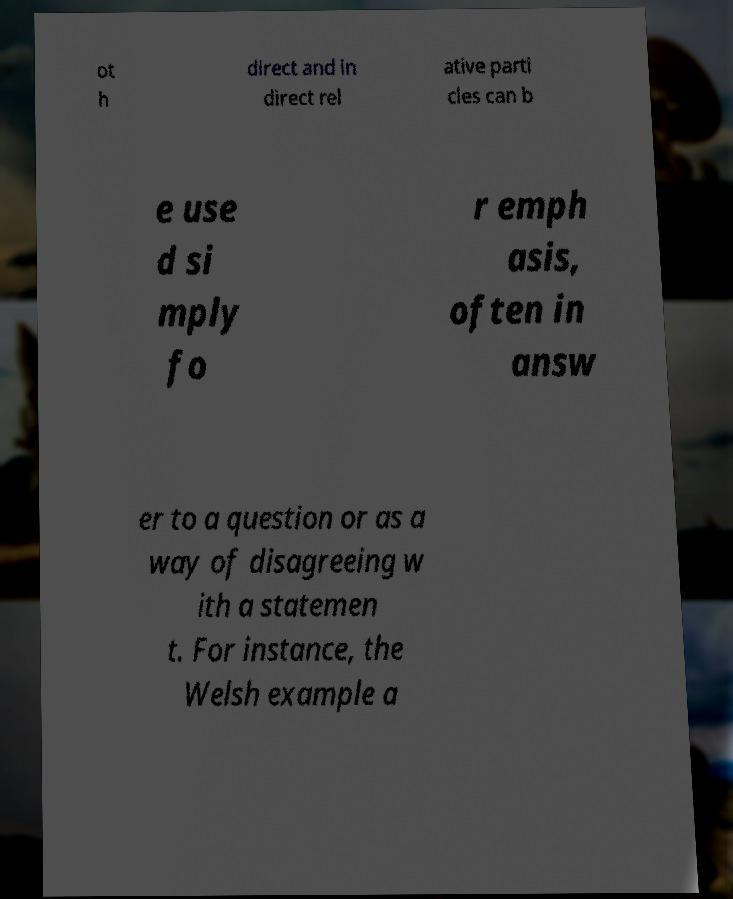Could you assist in decoding the text presented in this image and type it out clearly? ot h direct and in direct rel ative parti cles can b e use d si mply fo r emph asis, often in answ er to a question or as a way of disagreeing w ith a statemen t. For instance, the Welsh example a 